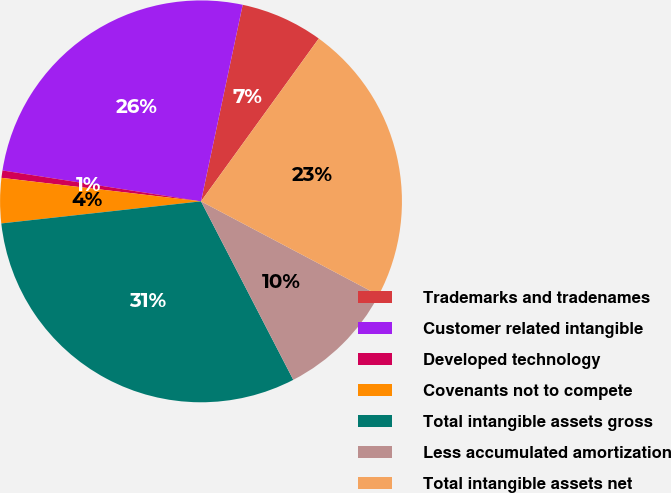Convert chart. <chart><loc_0><loc_0><loc_500><loc_500><pie_chart><fcel>Trademarks and tradenames<fcel>Customer related intangible<fcel>Developed technology<fcel>Covenants not to compete<fcel>Total intangible assets gross<fcel>Less accumulated amortization<fcel>Total intangible assets net<nl><fcel>6.64%<fcel>25.87%<fcel>0.59%<fcel>3.62%<fcel>30.84%<fcel>9.67%<fcel>22.77%<nl></chart> 